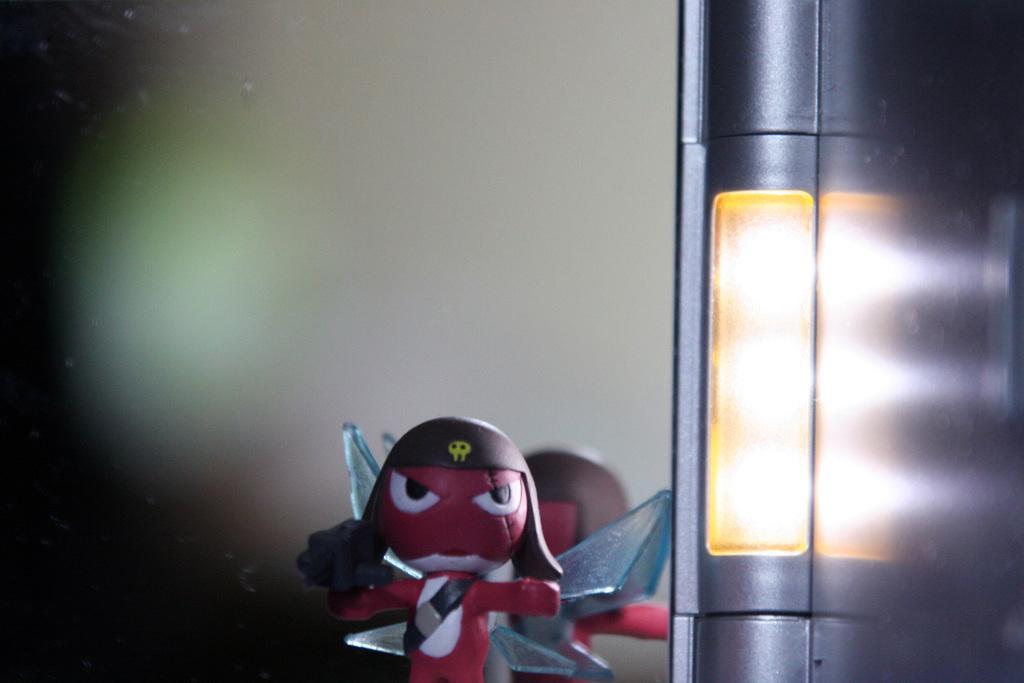In one or two sentences, can you explain what this image depicts? In this image in the foreground there is one toy, and on the right side there is one light and pole. The background is blurred. 